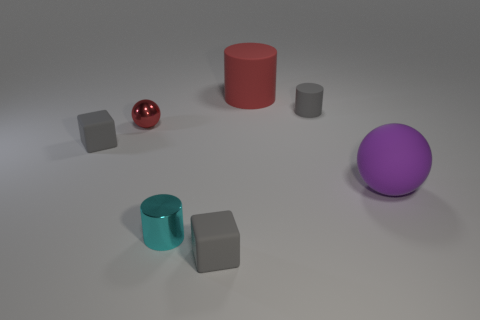Add 1 metallic spheres. How many objects exist? 8 Subtract all spheres. How many objects are left? 5 Subtract all tiny yellow cylinders. Subtract all tiny cylinders. How many objects are left? 5 Add 2 metal cylinders. How many metal cylinders are left? 3 Add 3 cyan matte things. How many cyan matte things exist? 3 Subtract 0 red blocks. How many objects are left? 7 